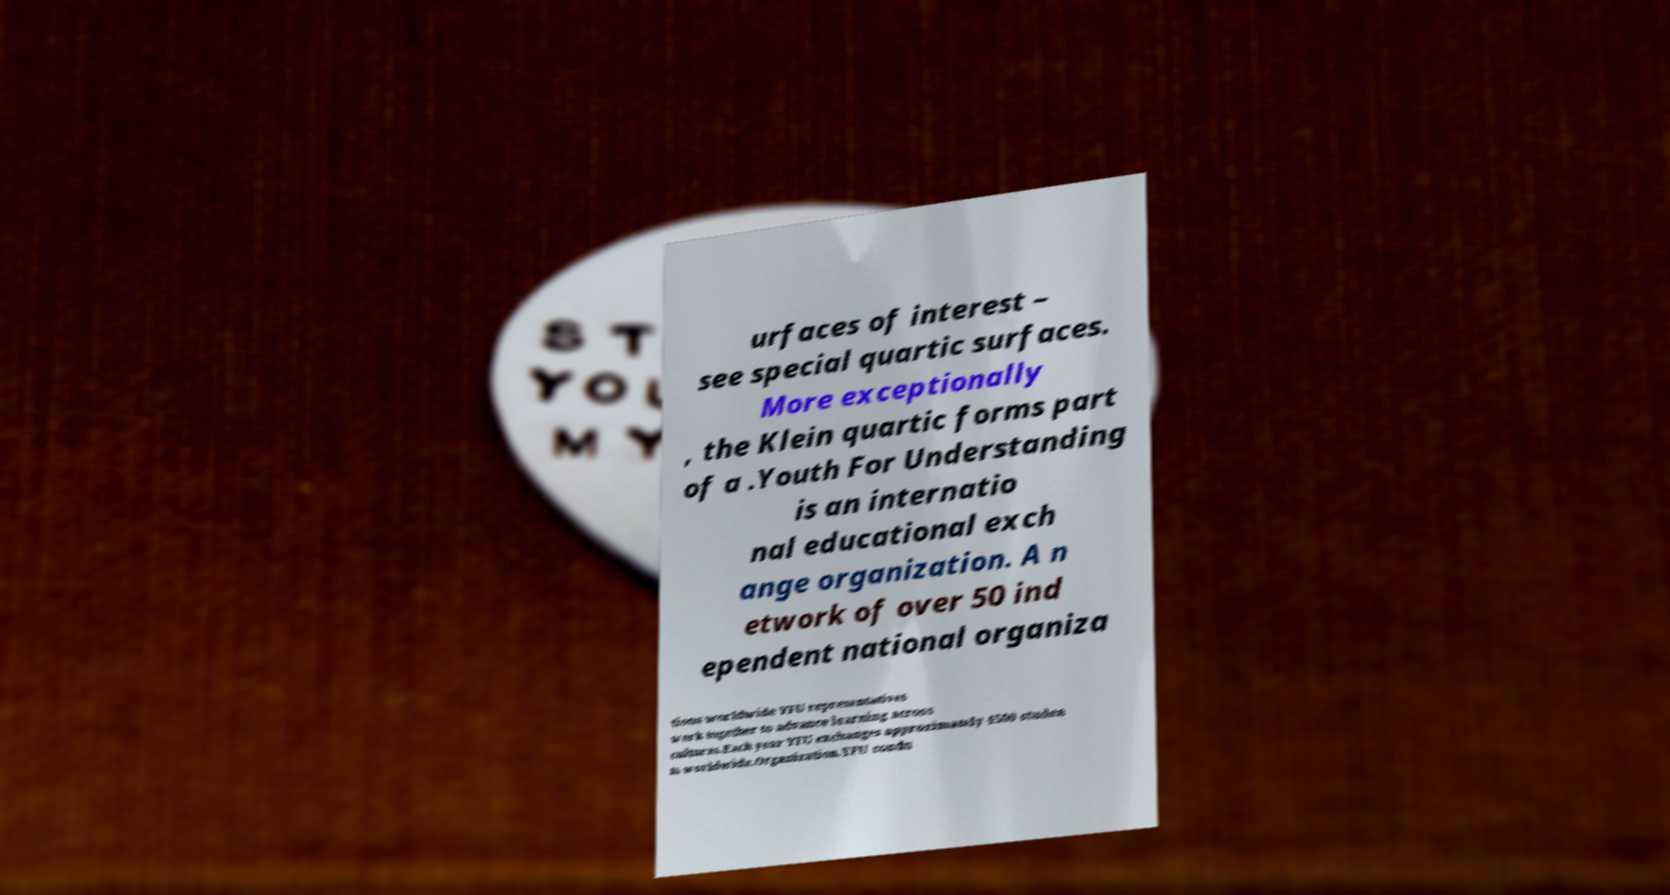I need the written content from this picture converted into text. Can you do that? urfaces of interest – see special quartic surfaces. More exceptionally , the Klein quartic forms part of a .Youth For Understanding is an internatio nal educational exch ange organization. A n etwork of over 50 ind ependent national organiza tions worldwide YFU representatives work together to advance learning across cultures.Each year YFU exchanges approximately 4500 studen ts worldwide.Organization.YFU condu 